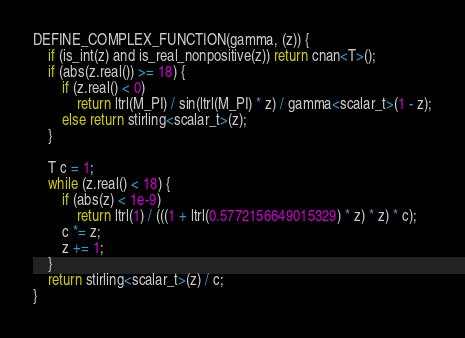Convert code to text. <code><loc_0><loc_0><loc_500><loc_500><_Cuda_>
DEFINE_COMPLEX_FUNCTION(gamma, (z)) {
    if (is_int(z) and is_real_nonpositive(z)) return cnan<T>();
    if (abs(z.real()) >= 18) {
        if (z.real() < 0)
            return ltrl(M_PI) / sin(ltrl(M_PI) * z) / gamma<scalar_t>(1 - z);
        else return stirling<scalar_t>(z);
    }

    T c = 1;
    while (z.real() < 18) {
        if (abs(z) < 1e-9)
            return ltrl(1) / (((1 + ltrl(0.5772156649015329) * z) * z) * c);
        c *= z;
        z += 1;
    }
    return stirling<scalar_t>(z) / c;
}
</code> 